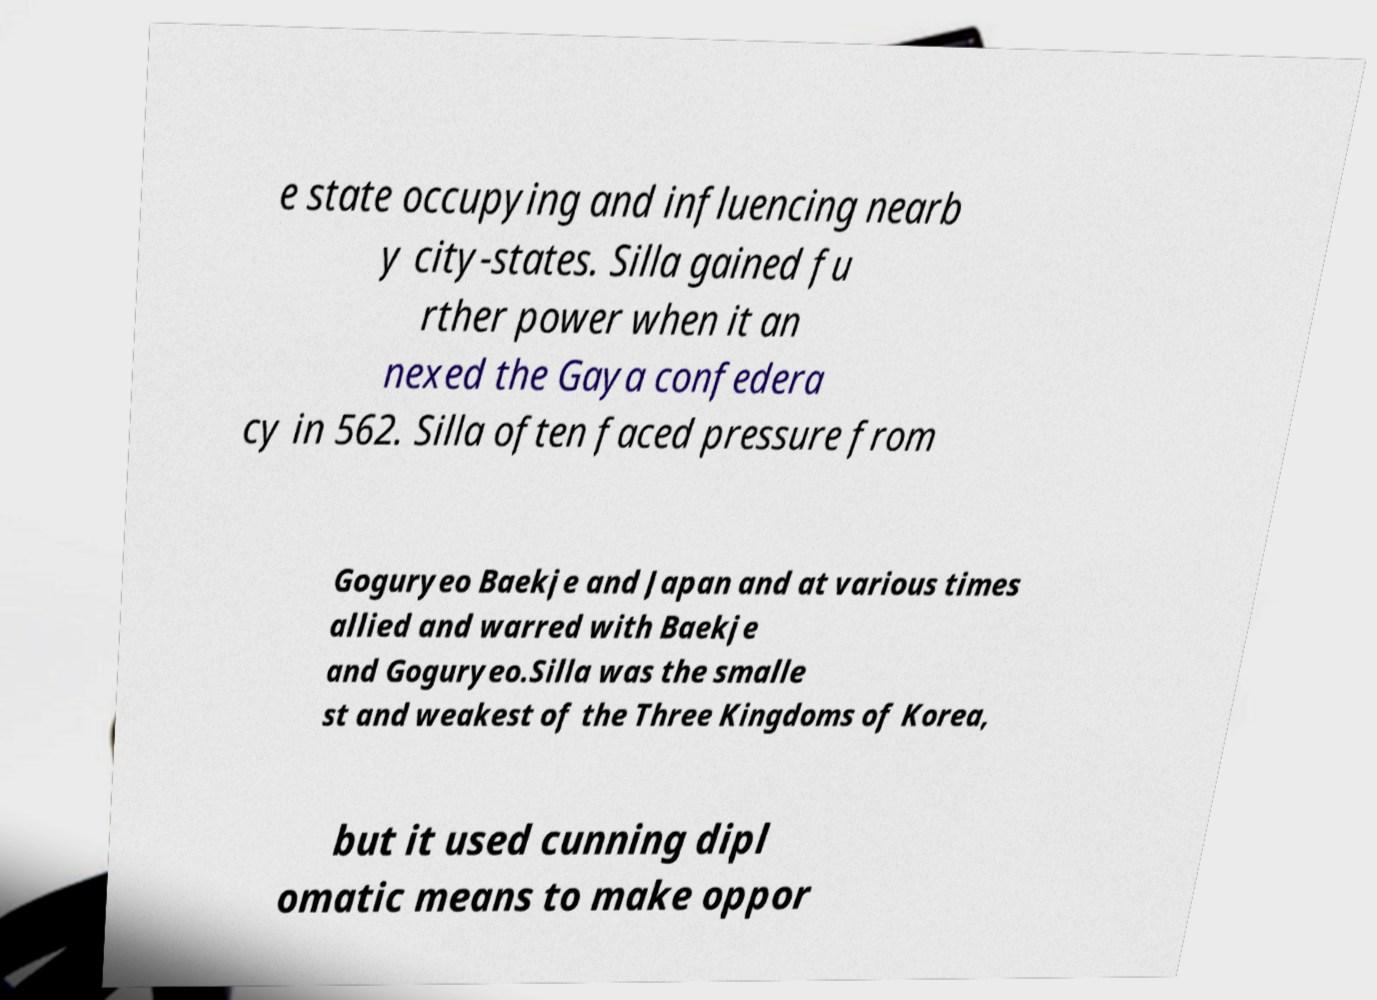Can you read and provide the text displayed in the image?This photo seems to have some interesting text. Can you extract and type it out for me? e state occupying and influencing nearb y city-states. Silla gained fu rther power when it an nexed the Gaya confedera cy in 562. Silla often faced pressure from Goguryeo Baekje and Japan and at various times allied and warred with Baekje and Goguryeo.Silla was the smalle st and weakest of the Three Kingdoms of Korea, but it used cunning dipl omatic means to make oppor 